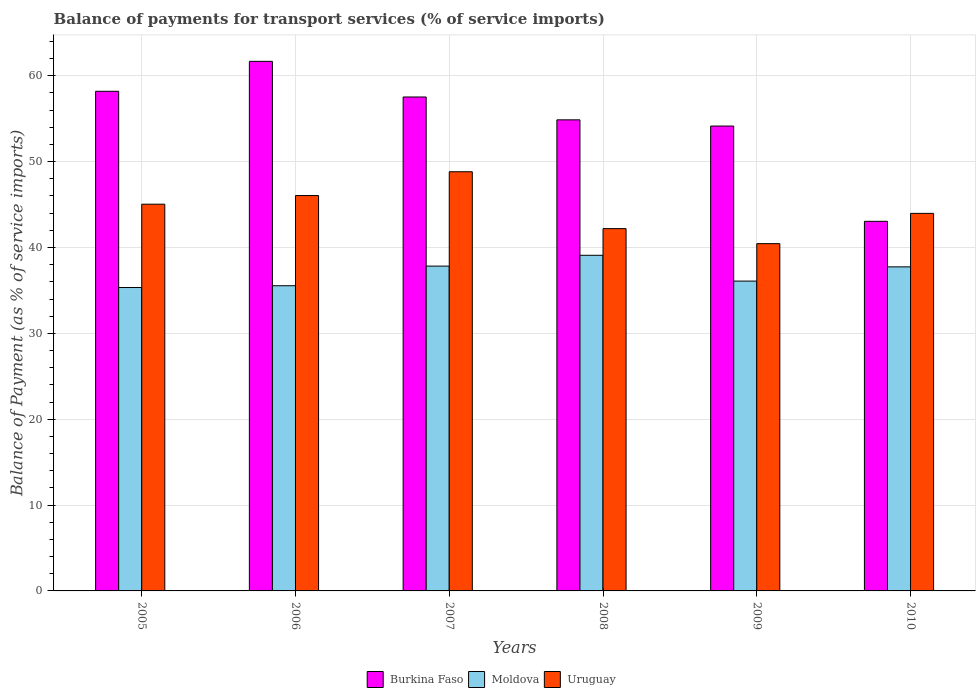How many different coloured bars are there?
Your answer should be compact. 3. How many groups of bars are there?
Your response must be concise. 6. Are the number of bars per tick equal to the number of legend labels?
Ensure brevity in your answer.  Yes. Are the number of bars on each tick of the X-axis equal?
Give a very brief answer. Yes. How many bars are there on the 3rd tick from the left?
Provide a short and direct response. 3. What is the balance of payments for transport services in Burkina Faso in 2009?
Give a very brief answer. 54.15. Across all years, what is the maximum balance of payments for transport services in Burkina Faso?
Keep it short and to the point. 61.68. Across all years, what is the minimum balance of payments for transport services in Uruguay?
Your answer should be very brief. 40.45. In which year was the balance of payments for transport services in Uruguay maximum?
Keep it short and to the point. 2007. In which year was the balance of payments for transport services in Uruguay minimum?
Your answer should be compact. 2009. What is the total balance of payments for transport services in Burkina Faso in the graph?
Your answer should be compact. 329.47. What is the difference between the balance of payments for transport services in Moldova in 2007 and that in 2009?
Provide a succinct answer. 1.74. What is the difference between the balance of payments for transport services in Uruguay in 2008 and the balance of payments for transport services in Moldova in 2006?
Offer a terse response. 6.65. What is the average balance of payments for transport services in Burkina Faso per year?
Keep it short and to the point. 54.91. In the year 2008, what is the difference between the balance of payments for transport services in Burkina Faso and balance of payments for transport services in Uruguay?
Provide a short and direct response. 12.67. What is the ratio of the balance of payments for transport services in Moldova in 2007 to that in 2008?
Provide a succinct answer. 0.97. What is the difference between the highest and the second highest balance of payments for transport services in Moldova?
Offer a terse response. 1.26. What is the difference between the highest and the lowest balance of payments for transport services in Burkina Faso?
Your answer should be very brief. 18.63. In how many years, is the balance of payments for transport services in Moldova greater than the average balance of payments for transport services in Moldova taken over all years?
Offer a terse response. 3. What does the 1st bar from the left in 2007 represents?
Your answer should be very brief. Burkina Faso. What does the 3rd bar from the right in 2007 represents?
Offer a very short reply. Burkina Faso. Are all the bars in the graph horizontal?
Your answer should be compact. No. What is the difference between two consecutive major ticks on the Y-axis?
Your response must be concise. 10. Are the values on the major ticks of Y-axis written in scientific E-notation?
Offer a very short reply. No. Where does the legend appear in the graph?
Ensure brevity in your answer.  Bottom center. How are the legend labels stacked?
Your answer should be compact. Horizontal. What is the title of the graph?
Offer a very short reply. Balance of payments for transport services (% of service imports). What is the label or title of the X-axis?
Your response must be concise. Years. What is the label or title of the Y-axis?
Offer a very short reply. Balance of Payment (as % of service imports). What is the Balance of Payment (as % of service imports) of Burkina Faso in 2005?
Give a very brief answer. 58.19. What is the Balance of Payment (as % of service imports) of Moldova in 2005?
Ensure brevity in your answer.  35.34. What is the Balance of Payment (as % of service imports) of Uruguay in 2005?
Make the answer very short. 45.04. What is the Balance of Payment (as % of service imports) in Burkina Faso in 2006?
Your answer should be compact. 61.68. What is the Balance of Payment (as % of service imports) of Moldova in 2006?
Your response must be concise. 35.55. What is the Balance of Payment (as % of service imports) of Uruguay in 2006?
Make the answer very short. 46.05. What is the Balance of Payment (as % of service imports) of Burkina Faso in 2007?
Keep it short and to the point. 57.53. What is the Balance of Payment (as % of service imports) in Moldova in 2007?
Your response must be concise. 37.83. What is the Balance of Payment (as % of service imports) in Uruguay in 2007?
Give a very brief answer. 48.82. What is the Balance of Payment (as % of service imports) of Burkina Faso in 2008?
Give a very brief answer. 54.87. What is the Balance of Payment (as % of service imports) of Moldova in 2008?
Make the answer very short. 39.09. What is the Balance of Payment (as % of service imports) in Uruguay in 2008?
Your answer should be very brief. 42.2. What is the Balance of Payment (as % of service imports) in Burkina Faso in 2009?
Ensure brevity in your answer.  54.15. What is the Balance of Payment (as % of service imports) of Moldova in 2009?
Your answer should be very brief. 36.09. What is the Balance of Payment (as % of service imports) of Uruguay in 2009?
Ensure brevity in your answer.  40.45. What is the Balance of Payment (as % of service imports) in Burkina Faso in 2010?
Provide a short and direct response. 43.05. What is the Balance of Payment (as % of service imports) in Moldova in 2010?
Ensure brevity in your answer.  37.74. What is the Balance of Payment (as % of service imports) of Uruguay in 2010?
Offer a very short reply. 43.98. Across all years, what is the maximum Balance of Payment (as % of service imports) of Burkina Faso?
Provide a succinct answer. 61.68. Across all years, what is the maximum Balance of Payment (as % of service imports) of Moldova?
Your answer should be very brief. 39.09. Across all years, what is the maximum Balance of Payment (as % of service imports) of Uruguay?
Provide a succinct answer. 48.82. Across all years, what is the minimum Balance of Payment (as % of service imports) of Burkina Faso?
Keep it short and to the point. 43.05. Across all years, what is the minimum Balance of Payment (as % of service imports) in Moldova?
Give a very brief answer. 35.34. Across all years, what is the minimum Balance of Payment (as % of service imports) in Uruguay?
Offer a terse response. 40.45. What is the total Balance of Payment (as % of service imports) in Burkina Faso in the graph?
Keep it short and to the point. 329.47. What is the total Balance of Payment (as % of service imports) in Moldova in the graph?
Provide a succinct answer. 221.64. What is the total Balance of Payment (as % of service imports) of Uruguay in the graph?
Ensure brevity in your answer.  266.54. What is the difference between the Balance of Payment (as % of service imports) of Burkina Faso in 2005 and that in 2006?
Make the answer very short. -3.49. What is the difference between the Balance of Payment (as % of service imports) in Moldova in 2005 and that in 2006?
Make the answer very short. -0.21. What is the difference between the Balance of Payment (as % of service imports) in Uruguay in 2005 and that in 2006?
Your answer should be very brief. -1.01. What is the difference between the Balance of Payment (as % of service imports) in Burkina Faso in 2005 and that in 2007?
Provide a short and direct response. 0.66. What is the difference between the Balance of Payment (as % of service imports) of Moldova in 2005 and that in 2007?
Make the answer very short. -2.49. What is the difference between the Balance of Payment (as % of service imports) in Uruguay in 2005 and that in 2007?
Offer a very short reply. -3.78. What is the difference between the Balance of Payment (as % of service imports) of Burkina Faso in 2005 and that in 2008?
Provide a short and direct response. 3.33. What is the difference between the Balance of Payment (as % of service imports) in Moldova in 2005 and that in 2008?
Offer a terse response. -3.75. What is the difference between the Balance of Payment (as % of service imports) of Uruguay in 2005 and that in 2008?
Keep it short and to the point. 2.85. What is the difference between the Balance of Payment (as % of service imports) of Burkina Faso in 2005 and that in 2009?
Offer a very short reply. 4.05. What is the difference between the Balance of Payment (as % of service imports) in Moldova in 2005 and that in 2009?
Your response must be concise. -0.75. What is the difference between the Balance of Payment (as % of service imports) of Uruguay in 2005 and that in 2009?
Make the answer very short. 4.59. What is the difference between the Balance of Payment (as % of service imports) of Burkina Faso in 2005 and that in 2010?
Your answer should be very brief. 15.14. What is the difference between the Balance of Payment (as % of service imports) in Moldova in 2005 and that in 2010?
Provide a succinct answer. -2.41. What is the difference between the Balance of Payment (as % of service imports) of Uruguay in 2005 and that in 2010?
Give a very brief answer. 1.07. What is the difference between the Balance of Payment (as % of service imports) in Burkina Faso in 2006 and that in 2007?
Your answer should be very brief. 4.15. What is the difference between the Balance of Payment (as % of service imports) of Moldova in 2006 and that in 2007?
Your answer should be very brief. -2.29. What is the difference between the Balance of Payment (as % of service imports) in Uruguay in 2006 and that in 2007?
Offer a terse response. -2.77. What is the difference between the Balance of Payment (as % of service imports) in Burkina Faso in 2006 and that in 2008?
Keep it short and to the point. 6.81. What is the difference between the Balance of Payment (as % of service imports) in Moldova in 2006 and that in 2008?
Offer a terse response. -3.55. What is the difference between the Balance of Payment (as % of service imports) of Uruguay in 2006 and that in 2008?
Give a very brief answer. 3.85. What is the difference between the Balance of Payment (as % of service imports) of Burkina Faso in 2006 and that in 2009?
Your response must be concise. 7.53. What is the difference between the Balance of Payment (as % of service imports) in Moldova in 2006 and that in 2009?
Keep it short and to the point. -0.54. What is the difference between the Balance of Payment (as % of service imports) of Uruguay in 2006 and that in 2009?
Ensure brevity in your answer.  5.6. What is the difference between the Balance of Payment (as % of service imports) of Burkina Faso in 2006 and that in 2010?
Your answer should be compact. 18.63. What is the difference between the Balance of Payment (as % of service imports) in Moldova in 2006 and that in 2010?
Offer a terse response. -2.2. What is the difference between the Balance of Payment (as % of service imports) in Uruguay in 2006 and that in 2010?
Offer a very short reply. 2.07. What is the difference between the Balance of Payment (as % of service imports) of Burkina Faso in 2007 and that in 2008?
Your response must be concise. 2.66. What is the difference between the Balance of Payment (as % of service imports) of Moldova in 2007 and that in 2008?
Provide a short and direct response. -1.26. What is the difference between the Balance of Payment (as % of service imports) of Uruguay in 2007 and that in 2008?
Offer a terse response. 6.63. What is the difference between the Balance of Payment (as % of service imports) of Burkina Faso in 2007 and that in 2009?
Your answer should be compact. 3.38. What is the difference between the Balance of Payment (as % of service imports) in Moldova in 2007 and that in 2009?
Offer a very short reply. 1.74. What is the difference between the Balance of Payment (as % of service imports) in Uruguay in 2007 and that in 2009?
Offer a terse response. 8.38. What is the difference between the Balance of Payment (as % of service imports) of Burkina Faso in 2007 and that in 2010?
Give a very brief answer. 14.48. What is the difference between the Balance of Payment (as % of service imports) in Moldova in 2007 and that in 2010?
Offer a terse response. 0.09. What is the difference between the Balance of Payment (as % of service imports) in Uruguay in 2007 and that in 2010?
Keep it short and to the point. 4.85. What is the difference between the Balance of Payment (as % of service imports) in Burkina Faso in 2008 and that in 2009?
Keep it short and to the point. 0.72. What is the difference between the Balance of Payment (as % of service imports) of Moldova in 2008 and that in 2009?
Your answer should be compact. 3. What is the difference between the Balance of Payment (as % of service imports) in Uruguay in 2008 and that in 2009?
Provide a succinct answer. 1.75. What is the difference between the Balance of Payment (as % of service imports) in Burkina Faso in 2008 and that in 2010?
Your response must be concise. 11.82. What is the difference between the Balance of Payment (as % of service imports) in Moldova in 2008 and that in 2010?
Offer a very short reply. 1.35. What is the difference between the Balance of Payment (as % of service imports) of Uruguay in 2008 and that in 2010?
Your answer should be very brief. -1.78. What is the difference between the Balance of Payment (as % of service imports) in Burkina Faso in 2009 and that in 2010?
Offer a very short reply. 11.1. What is the difference between the Balance of Payment (as % of service imports) of Moldova in 2009 and that in 2010?
Offer a terse response. -1.66. What is the difference between the Balance of Payment (as % of service imports) in Uruguay in 2009 and that in 2010?
Your answer should be very brief. -3.53. What is the difference between the Balance of Payment (as % of service imports) in Burkina Faso in 2005 and the Balance of Payment (as % of service imports) in Moldova in 2006?
Provide a succinct answer. 22.65. What is the difference between the Balance of Payment (as % of service imports) of Burkina Faso in 2005 and the Balance of Payment (as % of service imports) of Uruguay in 2006?
Your answer should be very brief. 12.14. What is the difference between the Balance of Payment (as % of service imports) of Moldova in 2005 and the Balance of Payment (as % of service imports) of Uruguay in 2006?
Ensure brevity in your answer.  -10.71. What is the difference between the Balance of Payment (as % of service imports) in Burkina Faso in 2005 and the Balance of Payment (as % of service imports) in Moldova in 2007?
Your answer should be very brief. 20.36. What is the difference between the Balance of Payment (as % of service imports) of Burkina Faso in 2005 and the Balance of Payment (as % of service imports) of Uruguay in 2007?
Provide a short and direct response. 9.37. What is the difference between the Balance of Payment (as % of service imports) of Moldova in 2005 and the Balance of Payment (as % of service imports) of Uruguay in 2007?
Give a very brief answer. -13.49. What is the difference between the Balance of Payment (as % of service imports) of Burkina Faso in 2005 and the Balance of Payment (as % of service imports) of Moldova in 2008?
Give a very brief answer. 19.1. What is the difference between the Balance of Payment (as % of service imports) of Burkina Faso in 2005 and the Balance of Payment (as % of service imports) of Uruguay in 2008?
Offer a very short reply. 16. What is the difference between the Balance of Payment (as % of service imports) of Moldova in 2005 and the Balance of Payment (as % of service imports) of Uruguay in 2008?
Keep it short and to the point. -6.86. What is the difference between the Balance of Payment (as % of service imports) of Burkina Faso in 2005 and the Balance of Payment (as % of service imports) of Moldova in 2009?
Your answer should be very brief. 22.11. What is the difference between the Balance of Payment (as % of service imports) in Burkina Faso in 2005 and the Balance of Payment (as % of service imports) in Uruguay in 2009?
Offer a terse response. 17.75. What is the difference between the Balance of Payment (as % of service imports) of Moldova in 2005 and the Balance of Payment (as % of service imports) of Uruguay in 2009?
Keep it short and to the point. -5.11. What is the difference between the Balance of Payment (as % of service imports) in Burkina Faso in 2005 and the Balance of Payment (as % of service imports) in Moldova in 2010?
Provide a short and direct response. 20.45. What is the difference between the Balance of Payment (as % of service imports) of Burkina Faso in 2005 and the Balance of Payment (as % of service imports) of Uruguay in 2010?
Your answer should be very brief. 14.22. What is the difference between the Balance of Payment (as % of service imports) of Moldova in 2005 and the Balance of Payment (as % of service imports) of Uruguay in 2010?
Offer a terse response. -8.64. What is the difference between the Balance of Payment (as % of service imports) in Burkina Faso in 2006 and the Balance of Payment (as % of service imports) in Moldova in 2007?
Ensure brevity in your answer.  23.85. What is the difference between the Balance of Payment (as % of service imports) of Burkina Faso in 2006 and the Balance of Payment (as % of service imports) of Uruguay in 2007?
Keep it short and to the point. 12.86. What is the difference between the Balance of Payment (as % of service imports) of Moldova in 2006 and the Balance of Payment (as % of service imports) of Uruguay in 2007?
Offer a terse response. -13.28. What is the difference between the Balance of Payment (as % of service imports) of Burkina Faso in 2006 and the Balance of Payment (as % of service imports) of Moldova in 2008?
Provide a short and direct response. 22.59. What is the difference between the Balance of Payment (as % of service imports) in Burkina Faso in 2006 and the Balance of Payment (as % of service imports) in Uruguay in 2008?
Give a very brief answer. 19.48. What is the difference between the Balance of Payment (as % of service imports) of Moldova in 2006 and the Balance of Payment (as % of service imports) of Uruguay in 2008?
Ensure brevity in your answer.  -6.65. What is the difference between the Balance of Payment (as % of service imports) of Burkina Faso in 2006 and the Balance of Payment (as % of service imports) of Moldova in 2009?
Your answer should be compact. 25.59. What is the difference between the Balance of Payment (as % of service imports) in Burkina Faso in 2006 and the Balance of Payment (as % of service imports) in Uruguay in 2009?
Give a very brief answer. 21.23. What is the difference between the Balance of Payment (as % of service imports) in Moldova in 2006 and the Balance of Payment (as % of service imports) in Uruguay in 2009?
Ensure brevity in your answer.  -4.9. What is the difference between the Balance of Payment (as % of service imports) in Burkina Faso in 2006 and the Balance of Payment (as % of service imports) in Moldova in 2010?
Offer a terse response. 23.94. What is the difference between the Balance of Payment (as % of service imports) in Burkina Faso in 2006 and the Balance of Payment (as % of service imports) in Uruguay in 2010?
Provide a short and direct response. 17.71. What is the difference between the Balance of Payment (as % of service imports) of Moldova in 2006 and the Balance of Payment (as % of service imports) of Uruguay in 2010?
Provide a short and direct response. -8.43. What is the difference between the Balance of Payment (as % of service imports) in Burkina Faso in 2007 and the Balance of Payment (as % of service imports) in Moldova in 2008?
Your response must be concise. 18.44. What is the difference between the Balance of Payment (as % of service imports) of Burkina Faso in 2007 and the Balance of Payment (as % of service imports) of Uruguay in 2008?
Offer a very short reply. 15.33. What is the difference between the Balance of Payment (as % of service imports) in Moldova in 2007 and the Balance of Payment (as % of service imports) in Uruguay in 2008?
Your answer should be compact. -4.36. What is the difference between the Balance of Payment (as % of service imports) of Burkina Faso in 2007 and the Balance of Payment (as % of service imports) of Moldova in 2009?
Offer a very short reply. 21.44. What is the difference between the Balance of Payment (as % of service imports) of Burkina Faso in 2007 and the Balance of Payment (as % of service imports) of Uruguay in 2009?
Your answer should be very brief. 17.08. What is the difference between the Balance of Payment (as % of service imports) of Moldova in 2007 and the Balance of Payment (as % of service imports) of Uruguay in 2009?
Your answer should be compact. -2.62. What is the difference between the Balance of Payment (as % of service imports) of Burkina Faso in 2007 and the Balance of Payment (as % of service imports) of Moldova in 2010?
Give a very brief answer. 19.79. What is the difference between the Balance of Payment (as % of service imports) of Burkina Faso in 2007 and the Balance of Payment (as % of service imports) of Uruguay in 2010?
Offer a terse response. 13.55. What is the difference between the Balance of Payment (as % of service imports) of Moldova in 2007 and the Balance of Payment (as % of service imports) of Uruguay in 2010?
Offer a very short reply. -6.14. What is the difference between the Balance of Payment (as % of service imports) of Burkina Faso in 2008 and the Balance of Payment (as % of service imports) of Moldova in 2009?
Offer a very short reply. 18.78. What is the difference between the Balance of Payment (as % of service imports) of Burkina Faso in 2008 and the Balance of Payment (as % of service imports) of Uruguay in 2009?
Your response must be concise. 14.42. What is the difference between the Balance of Payment (as % of service imports) in Moldova in 2008 and the Balance of Payment (as % of service imports) in Uruguay in 2009?
Offer a terse response. -1.36. What is the difference between the Balance of Payment (as % of service imports) in Burkina Faso in 2008 and the Balance of Payment (as % of service imports) in Moldova in 2010?
Give a very brief answer. 17.12. What is the difference between the Balance of Payment (as % of service imports) in Burkina Faso in 2008 and the Balance of Payment (as % of service imports) in Uruguay in 2010?
Your answer should be very brief. 10.89. What is the difference between the Balance of Payment (as % of service imports) in Moldova in 2008 and the Balance of Payment (as % of service imports) in Uruguay in 2010?
Give a very brief answer. -4.88. What is the difference between the Balance of Payment (as % of service imports) of Burkina Faso in 2009 and the Balance of Payment (as % of service imports) of Moldova in 2010?
Make the answer very short. 16.4. What is the difference between the Balance of Payment (as % of service imports) of Burkina Faso in 2009 and the Balance of Payment (as % of service imports) of Uruguay in 2010?
Make the answer very short. 10.17. What is the difference between the Balance of Payment (as % of service imports) in Moldova in 2009 and the Balance of Payment (as % of service imports) in Uruguay in 2010?
Give a very brief answer. -7.89. What is the average Balance of Payment (as % of service imports) in Burkina Faso per year?
Keep it short and to the point. 54.91. What is the average Balance of Payment (as % of service imports) in Moldova per year?
Make the answer very short. 36.94. What is the average Balance of Payment (as % of service imports) of Uruguay per year?
Your answer should be very brief. 44.42. In the year 2005, what is the difference between the Balance of Payment (as % of service imports) in Burkina Faso and Balance of Payment (as % of service imports) in Moldova?
Your response must be concise. 22.86. In the year 2005, what is the difference between the Balance of Payment (as % of service imports) of Burkina Faso and Balance of Payment (as % of service imports) of Uruguay?
Your answer should be compact. 13.15. In the year 2005, what is the difference between the Balance of Payment (as % of service imports) of Moldova and Balance of Payment (as % of service imports) of Uruguay?
Your answer should be very brief. -9.7. In the year 2006, what is the difference between the Balance of Payment (as % of service imports) of Burkina Faso and Balance of Payment (as % of service imports) of Moldova?
Give a very brief answer. 26.13. In the year 2006, what is the difference between the Balance of Payment (as % of service imports) of Burkina Faso and Balance of Payment (as % of service imports) of Uruguay?
Offer a terse response. 15.63. In the year 2006, what is the difference between the Balance of Payment (as % of service imports) in Moldova and Balance of Payment (as % of service imports) in Uruguay?
Ensure brevity in your answer.  -10.5. In the year 2007, what is the difference between the Balance of Payment (as % of service imports) in Burkina Faso and Balance of Payment (as % of service imports) in Moldova?
Give a very brief answer. 19.7. In the year 2007, what is the difference between the Balance of Payment (as % of service imports) of Burkina Faso and Balance of Payment (as % of service imports) of Uruguay?
Provide a succinct answer. 8.71. In the year 2007, what is the difference between the Balance of Payment (as % of service imports) of Moldova and Balance of Payment (as % of service imports) of Uruguay?
Offer a very short reply. -10.99. In the year 2008, what is the difference between the Balance of Payment (as % of service imports) in Burkina Faso and Balance of Payment (as % of service imports) in Moldova?
Offer a very short reply. 15.77. In the year 2008, what is the difference between the Balance of Payment (as % of service imports) of Burkina Faso and Balance of Payment (as % of service imports) of Uruguay?
Ensure brevity in your answer.  12.67. In the year 2008, what is the difference between the Balance of Payment (as % of service imports) in Moldova and Balance of Payment (as % of service imports) in Uruguay?
Offer a terse response. -3.1. In the year 2009, what is the difference between the Balance of Payment (as % of service imports) in Burkina Faso and Balance of Payment (as % of service imports) in Moldova?
Offer a terse response. 18.06. In the year 2009, what is the difference between the Balance of Payment (as % of service imports) in Burkina Faso and Balance of Payment (as % of service imports) in Uruguay?
Your answer should be very brief. 13.7. In the year 2009, what is the difference between the Balance of Payment (as % of service imports) in Moldova and Balance of Payment (as % of service imports) in Uruguay?
Provide a short and direct response. -4.36. In the year 2010, what is the difference between the Balance of Payment (as % of service imports) of Burkina Faso and Balance of Payment (as % of service imports) of Moldova?
Offer a very short reply. 5.3. In the year 2010, what is the difference between the Balance of Payment (as % of service imports) of Burkina Faso and Balance of Payment (as % of service imports) of Uruguay?
Ensure brevity in your answer.  -0.93. In the year 2010, what is the difference between the Balance of Payment (as % of service imports) of Moldova and Balance of Payment (as % of service imports) of Uruguay?
Provide a succinct answer. -6.23. What is the ratio of the Balance of Payment (as % of service imports) in Burkina Faso in 2005 to that in 2006?
Provide a succinct answer. 0.94. What is the ratio of the Balance of Payment (as % of service imports) in Moldova in 2005 to that in 2006?
Your answer should be very brief. 0.99. What is the ratio of the Balance of Payment (as % of service imports) in Uruguay in 2005 to that in 2006?
Offer a terse response. 0.98. What is the ratio of the Balance of Payment (as % of service imports) of Burkina Faso in 2005 to that in 2007?
Make the answer very short. 1.01. What is the ratio of the Balance of Payment (as % of service imports) of Moldova in 2005 to that in 2007?
Your answer should be compact. 0.93. What is the ratio of the Balance of Payment (as % of service imports) in Uruguay in 2005 to that in 2007?
Your response must be concise. 0.92. What is the ratio of the Balance of Payment (as % of service imports) of Burkina Faso in 2005 to that in 2008?
Make the answer very short. 1.06. What is the ratio of the Balance of Payment (as % of service imports) of Moldova in 2005 to that in 2008?
Give a very brief answer. 0.9. What is the ratio of the Balance of Payment (as % of service imports) in Uruguay in 2005 to that in 2008?
Your answer should be compact. 1.07. What is the ratio of the Balance of Payment (as % of service imports) in Burkina Faso in 2005 to that in 2009?
Ensure brevity in your answer.  1.07. What is the ratio of the Balance of Payment (as % of service imports) of Moldova in 2005 to that in 2009?
Keep it short and to the point. 0.98. What is the ratio of the Balance of Payment (as % of service imports) in Uruguay in 2005 to that in 2009?
Keep it short and to the point. 1.11. What is the ratio of the Balance of Payment (as % of service imports) in Burkina Faso in 2005 to that in 2010?
Make the answer very short. 1.35. What is the ratio of the Balance of Payment (as % of service imports) in Moldova in 2005 to that in 2010?
Offer a terse response. 0.94. What is the ratio of the Balance of Payment (as % of service imports) of Uruguay in 2005 to that in 2010?
Make the answer very short. 1.02. What is the ratio of the Balance of Payment (as % of service imports) of Burkina Faso in 2006 to that in 2007?
Give a very brief answer. 1.07. What is the ratio of the Balance of Payment (as % of service imports) in Moldova in 2006 to that in 2007?
Ensure brevity in your answer.  0.94. What is the ratio of the Balance of Payment (as % of service imports) of Uruguay in 2006 to that in 2007?
Keep it short and to the point. 0.94. What is the ratio of the Balance of Payment (as % of service imports) of Burkina Faso in 2006 to that in 2008?
Make the answer very short. 1.12. What is the ratio of the Balance of Payment (as % of service imports) of Moldova in 2006 to that in 2008?
Make the answer very short. 0.91. What is the ratio of the Balance of Payment (as % of service imports) in Uruguay in 2006 to that in 2008?
Your response must be concise. 1.09. What is the ratio of the Balance of Payment (as % of service imports) in Burkina Faso in 2006 to that in 2009?
Ensure brevity in your answer.  1.14. What is the ratio of the Balance of Payment (as % of service imports) of Moldova in 2006 to that in 2009?
Your answer should be very brief. 0.98. What is the ratio of the Balance of Payment (as % of service imports) in Uruguay in 2006 to that in 2009?
Provide a succinct answer. 1.14. What is the ratio of the Balance of Payment (as % of service imports) of Burkina Faso in 2006 to that in 2010?
Ensure brevity in your answer.  1.43. What is the ratio of the Balance of Payment (as % of service imports) of Moldova in 2006 to that in 2010?
Your answer should be compact. 0.94. What is the ratio of the Balance of Payment (as % of service imports) in Uruguay in 2006 to that in 2010?
Your answer should be very brief. 1.05. What is the ratio of the Balance of Payment (as % of service imports) in Burkina Faso in 2007 to that in 2008?
Provide a succinct answer. 1.05. What is the ratio of the Balance of Payment (as % of service imports) in Moldova in 2007 to that in 2008?
Keep it short and to the point. 0.97. What is the ratio of the Balance of Payment (as % of service imports) in Uruguay in 2007 to that in 2008?
Provide a succinct answer. 1.16. What is the ratio of the Balance of Payment (as % of service imports) in Moldova in 2007 to that in 2009?
Ensure brevity in your answer.  1.05. What is the ratio of the Balance of Payment (as % of service imports) in Uruguay in 2007 to that in 2009?
Your answer should be very brief. 1.21. What is the ratio of the Balance of Payment (as % of service imports) of Burkina Faso in 2007 to that in 2010?
Ensure brevity in your answer.  1.34. What is the ratio of the Balance of Payment (as % of service imports) of Moldova in 2007 to that in 2010?
Keep it short and to the point. 1. What is the ratio of the Balance of Payment (as % of service imports) of Uruguay in 2007 to that in 2010?
Ensure brevity in your answer.  1.11. What is the ratio of the Balance of Payment (as % of service imports) in Burkina Faso in 2008 to that in 2009?
Ensure brevity in your answer.  1.01. What is the ratio of the Balance of Payment (as % of service imports) in Uruguay in 2008 to that in 2009?
Your response must be concise. 1.04. What is the ratio of the Balance of Payment (as % of service imports) in Burkina Faso in 2008 to that in 2010?
Offer a very short reply. 1.27. What is the ratio of the Balance of Payment (as % of service imports) of Moldova in 2008 to that in 2010?
Provide a short and direct response. 1.04. What is the ratio of the Balance of Payment (as % of service imports) of Uruguay in 2008 to that in 2010?
Ensure brevity in your answer.  0.96. What is the ratio of the Balance of Payment (as % of service imports) in Burkina Faso in 2009 to that in 2010?
Your response must be concise. 1.26. What is the ratio of the Balance of Payment (as % of service imports) of Moldova in 2009 to that in 2010?
Your response must be concise. 0.96. What is the ratio of the Balance of Payment (as % of service imports) in Uruguay in 2009 to that in 2010?
Your response must be concise. 0.92. What is the difference between the highest and the second highest Balance of Payment (as % of service imports) of Burkina Faso?
Your answer should be compact. 3.49. What is the difference between the highest and the second highest Balance of Payment (as % of service imports) in Moldova?
Offer a very short reply. 1.26. What is the difference between the highest and the second highest Balance of Payment (as % of service imports) in Uruguay?
Your response must be concise. 2.77. What is the difference between the highest and the lowest Balance of Payment (as % of service imports) of Burkina Faso?
Keep it short and to the point. 18.63. What is the difference between the highest and the lowest Balance of Payment (as % of service imports) in Moldova?
Keep it short and to the point. 3.75. What is the difference between the highest and the lowest Balance of Payment (as % of service imports) in Uruguay?
Give a very brief answer. 8.38. 